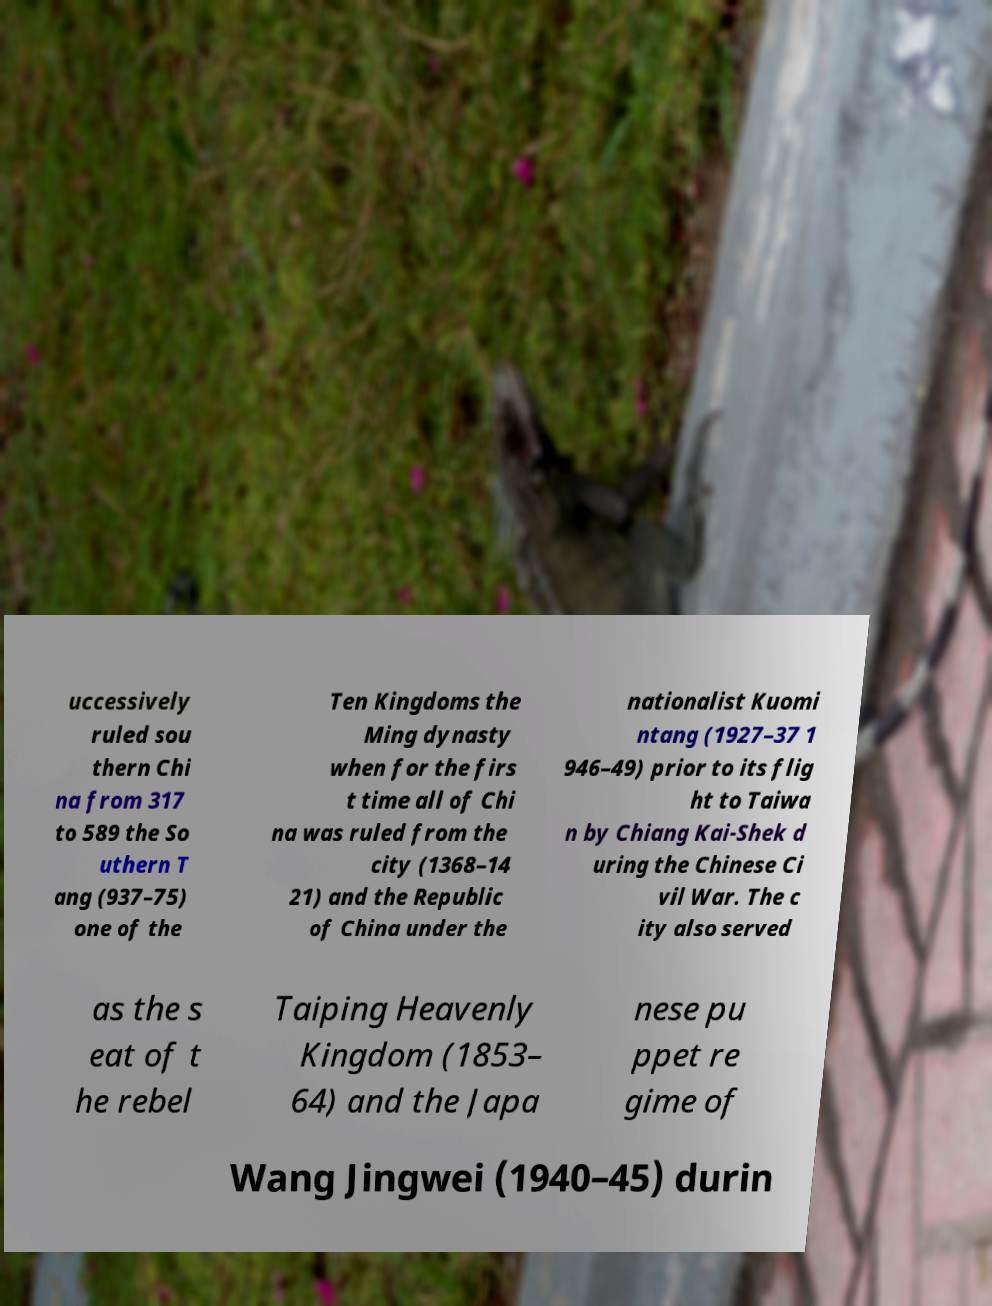Could you extract and type out the text from this image? uccessively ruled sou thern Chi na from 317 to 589 the So uthern T ang (937–75) one of the Ten Kingdoms the Ming dynasty when for the firs t time all of Chi na was ruled from the city (1368–14 21) and the Republic of China under the nationalist Kuomi ntang (1927–37 1 946–49) prior to its flig ht to Taiwa n by Chiang Kai-Shek d uring the Chinese Ci vil War. The c ity also served as the s eat of t he rebel Taiping Heavenly Kingdom (1853– 64) and the Japa nese pu ppet re gime of Wang Jingwei (1940–45) durin 